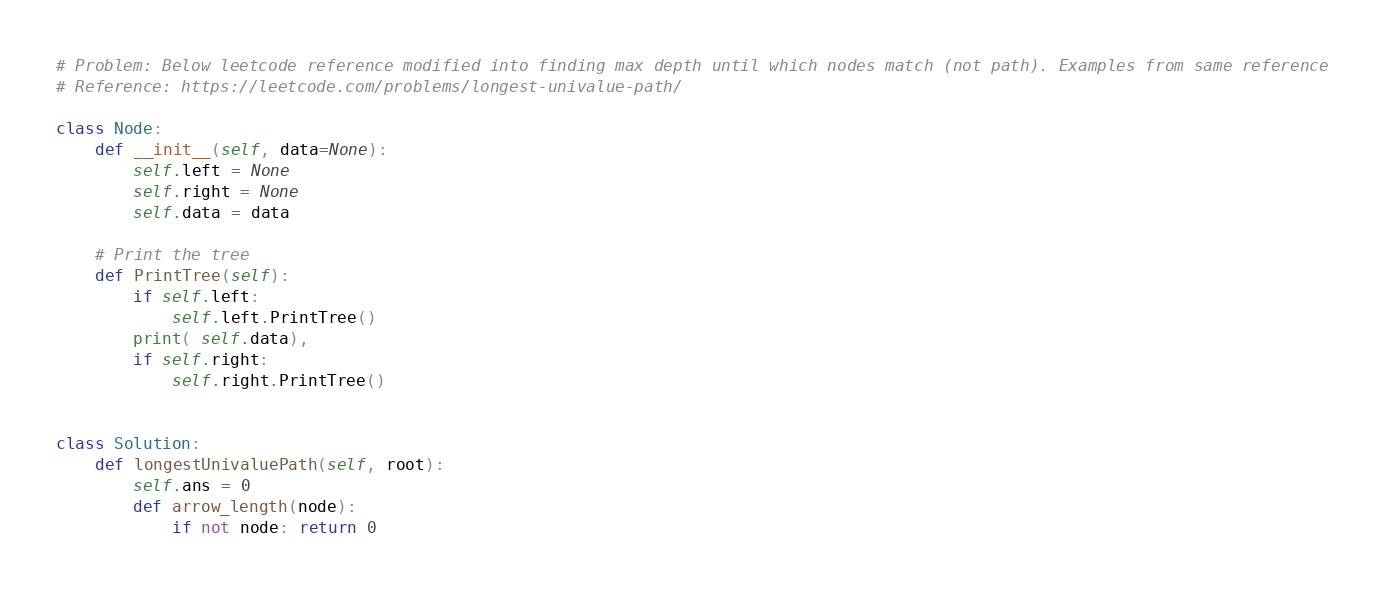<code> <loc_0><loc_0><loc_500><loc_500><_Python_># Problem: Below leetcode reference modified into finding max depth until which nodes match (not path). Examples from same reference
# Reference: https://leetcode.com/problems/longest-univalue-path/

class Node:
    def __init__(self, data=None):
        self.left = None
        self.right = None
        self.data = data

    # Print the tree
    def PrintTree(self):
        if self.left:
            self.left.PrintTree()
        print( self.data),
        if self.right:
            self.right.PrintTree()


class Solution:
    def longestUnivaluePath(self, root):
        self.ans = 0
        def arrow_length(node):
            if not node: return 0</code> 